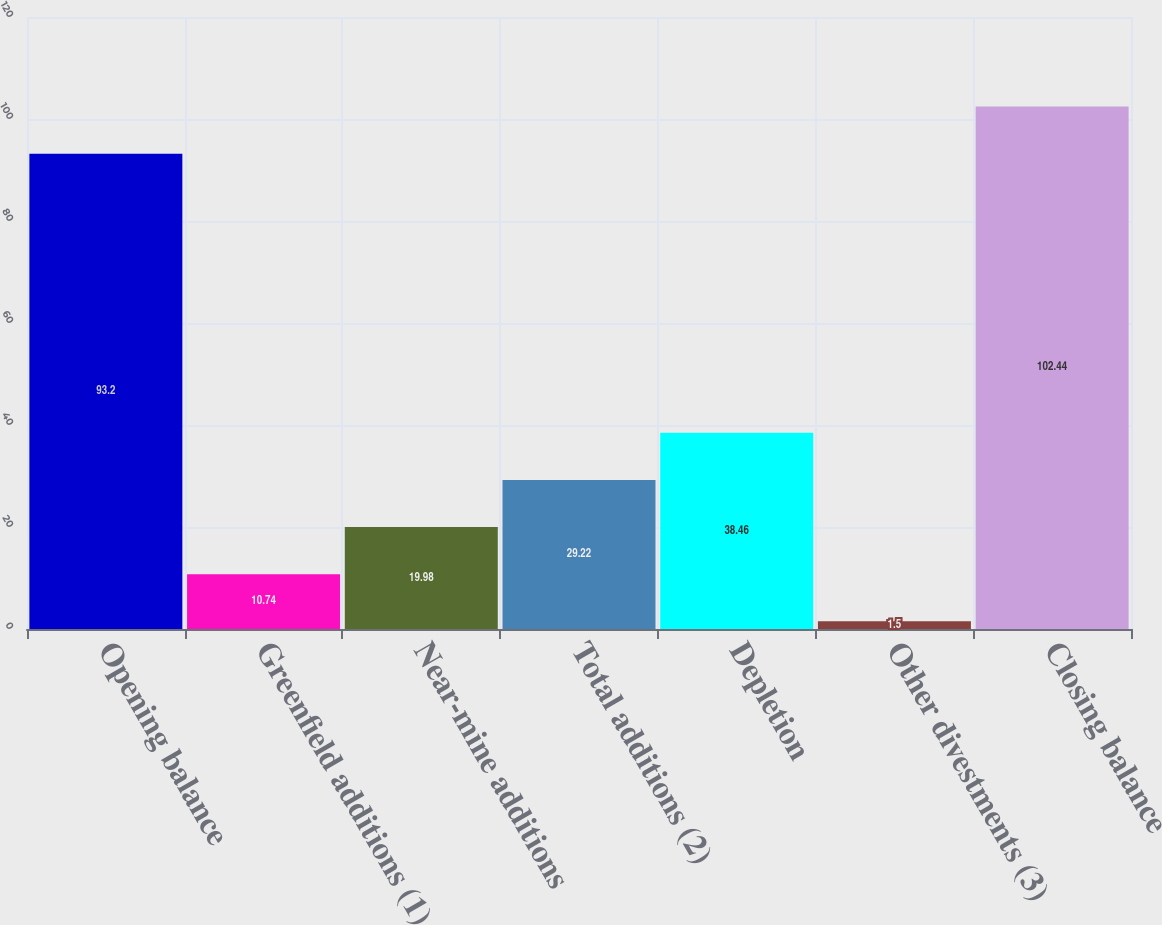Convert chart to OTSL. <chart><loc_0><loc_0><loc_500><loc_500><bar_chart><fcel>Opening balance<fcel>Greenfield additions (1)<fcel>Near-mine additions<fcel>Total additions (2)<fcel>Depletion<fcel>Other divestments (3)<fcel>Closing balance<nl><fcel>93.2<fcel>10.74<fcel>19.98<fcel>29.22<fcel>38.46<fcel>1.5<fcel>102.44<nl></chart> 